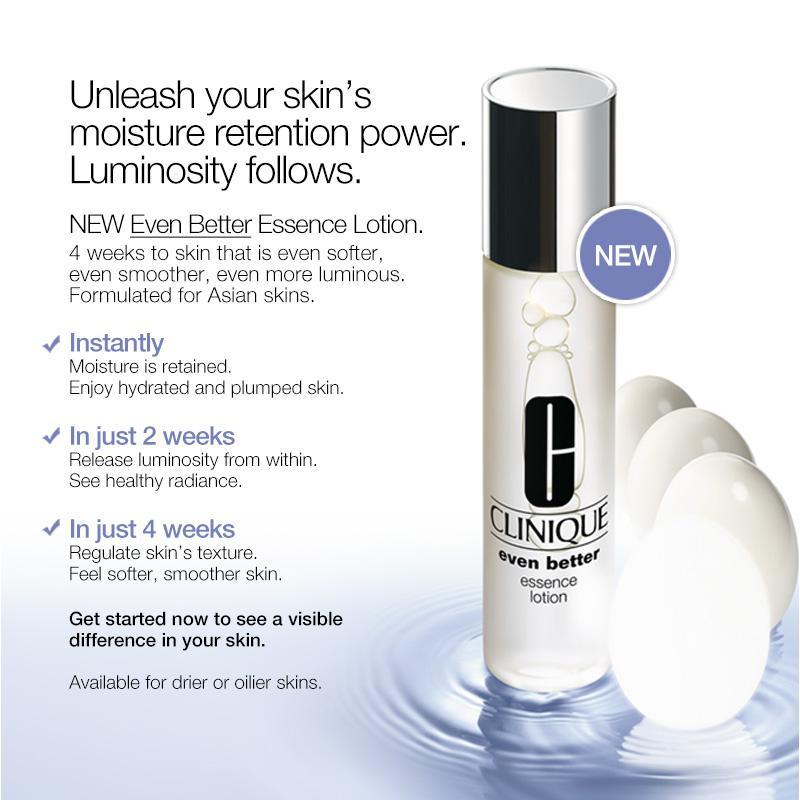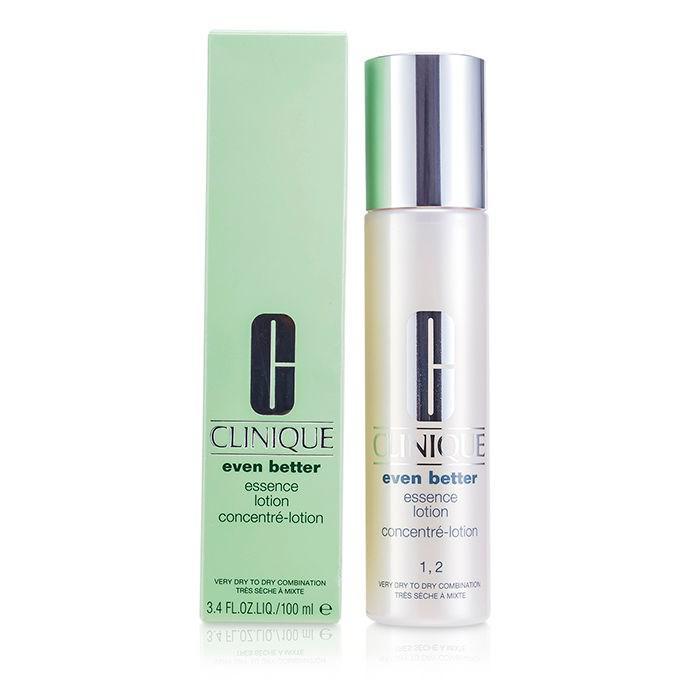The first image is the image on the left, the second image is the image on the right. Considering the images on both sides, is "An image shows a cylindrical upright bottle creating ripples in a pool of water." valid? Answer yes or no. Yes. 